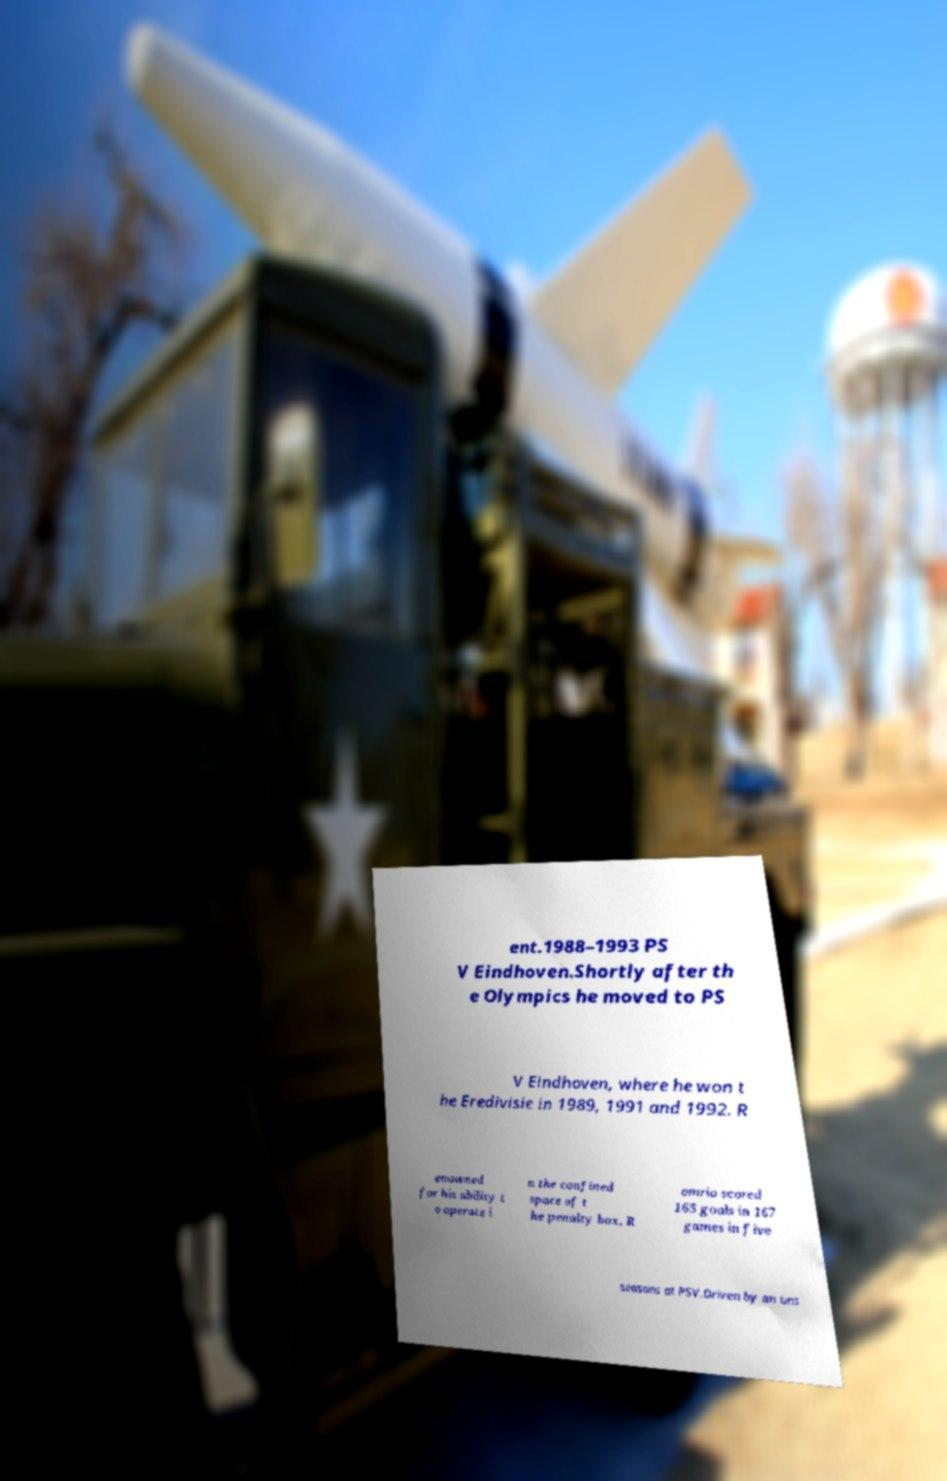Could you extract and type out the text from this image? ent.1988–1993 PS V Eindhoven.Shortly after th e Olympics he moved to PS V Eindhoven, where he won t he Eredivisie in 1989, 1991 and 1992. R enowned for his ability t o operate i n the confined space of t he penalty box, R omrio scored 165 goals in 167 games in five seasons at PSV.Driven by an uns 